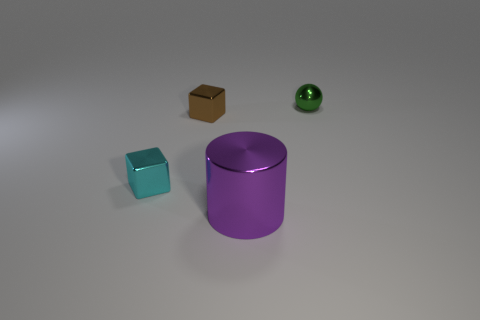Add 4 large purple metal cylinders. How many objects exist? 8 Subtract all cylinders. How many objects are left? 3 Add 1 blue rubber things. How many blue rubber things exist? 1 Subtract 0 purple balls. How many objects are left? 4 Subtract all tiny balls. Subtract all brown things. How many objects are left? 2 Add 1 purple things. How many purple things are left? 2 